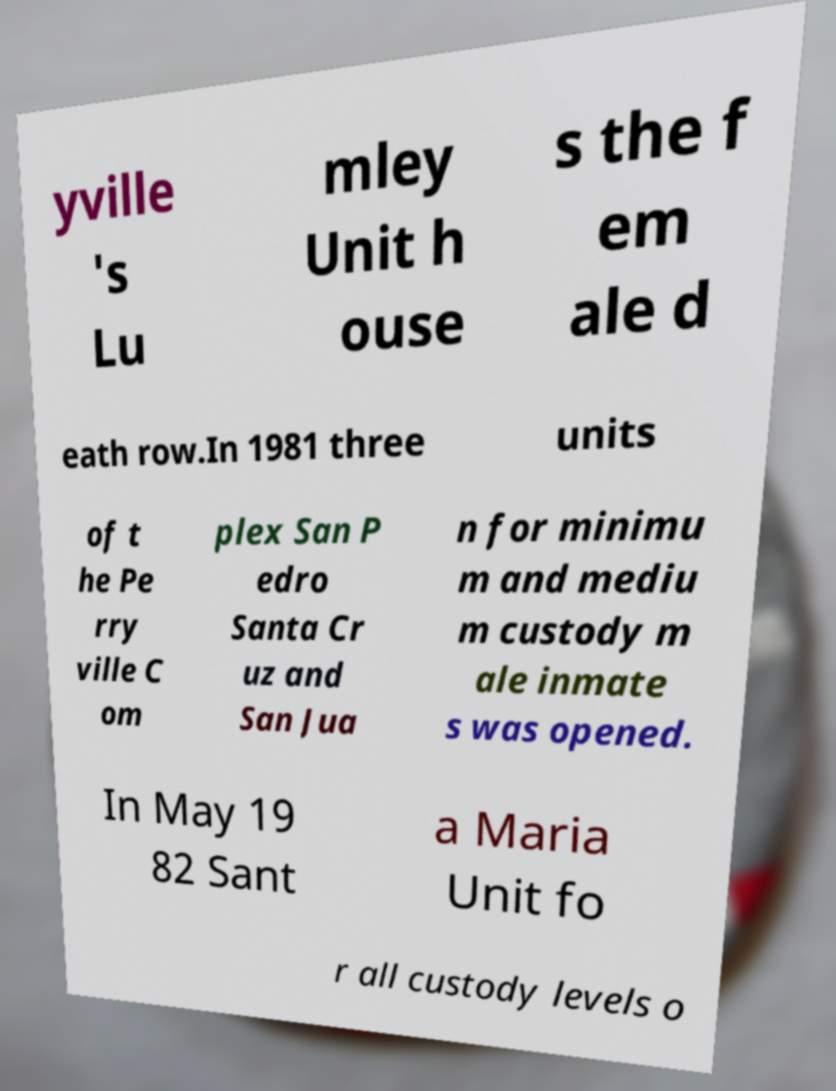What messages or text are displayed in this image? I need them in a readable, typed format. yville 's Lu mley Unit h ouse s the f em ale d eath row.In 1981 three units of t he Pe rry ville C om plex San P edro Santa Cr uz and San Jua n for minimu m and mediu m custody m ale inmate s was opened. In May 19 82 Sant a Maria Unit fo r all custody levels o 